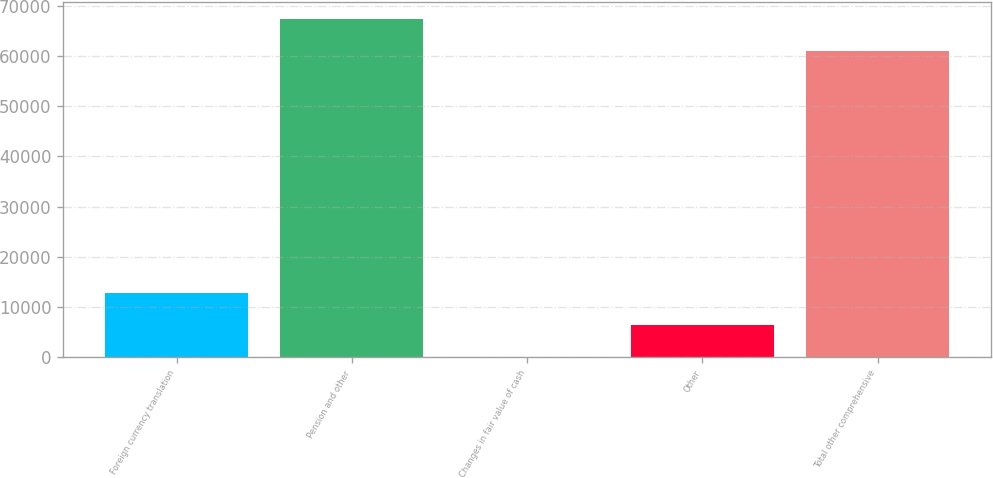Convert chart. <chart><loc_0><loc_0><loc_500><loc_500><bar_chart><fcel>Foreign currency translation<fcel>Pension and other<fcel>Changes in fair value of cash<fcel>Other<fcel>Total other comprehensive<nl><fcel>12737.8<fcel>67343.9<fcel>26<fcel>6381.9<fcel>60988<nl></chart> 